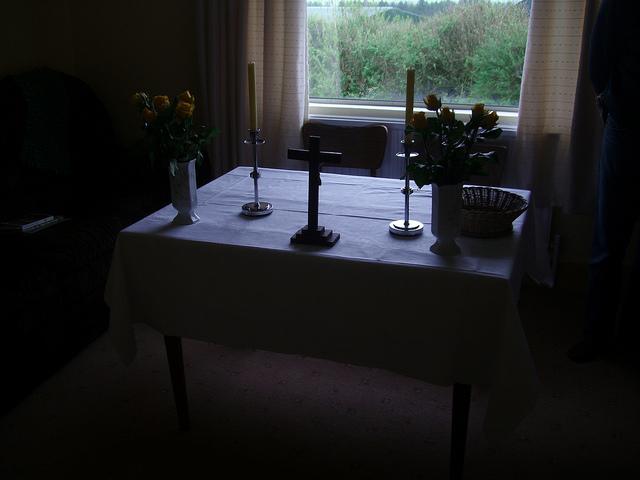Is this a bedroom?
Keep it brief. No. Are there any books on the table?
Short answer required. No. Is it a sunny or rainy day?
Short answer required. Rainy. If the window in this picture is facing east, what time of day is it?
Concise answer only. Afternoon. Is this a room for eating?
Keep it brief. Yes. What room is this?
Answer briefly. Dining room. Are the candles lit?
Be succinct. No. How many candles are there?
Give a very brief answer. 2. Is this room dark?
Quick response, please. Yes. Is the room growing darker?
Short answer required. Yes. Is the vase on a glass table?
Be succinct. No. Yes the room is getting darker.On the candles are not lit?
Quick response, please. Yes. 